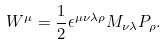Convert formula to latex. <formula><loc_0><loc_0><loc_500><loc_500>W ^ { \mu } = \frac { 1 } { 2 } \epsilon ^ { \mu \nu \lambda \rho } M _ { \nu \lambda } P _ { \rho } .</formula> 